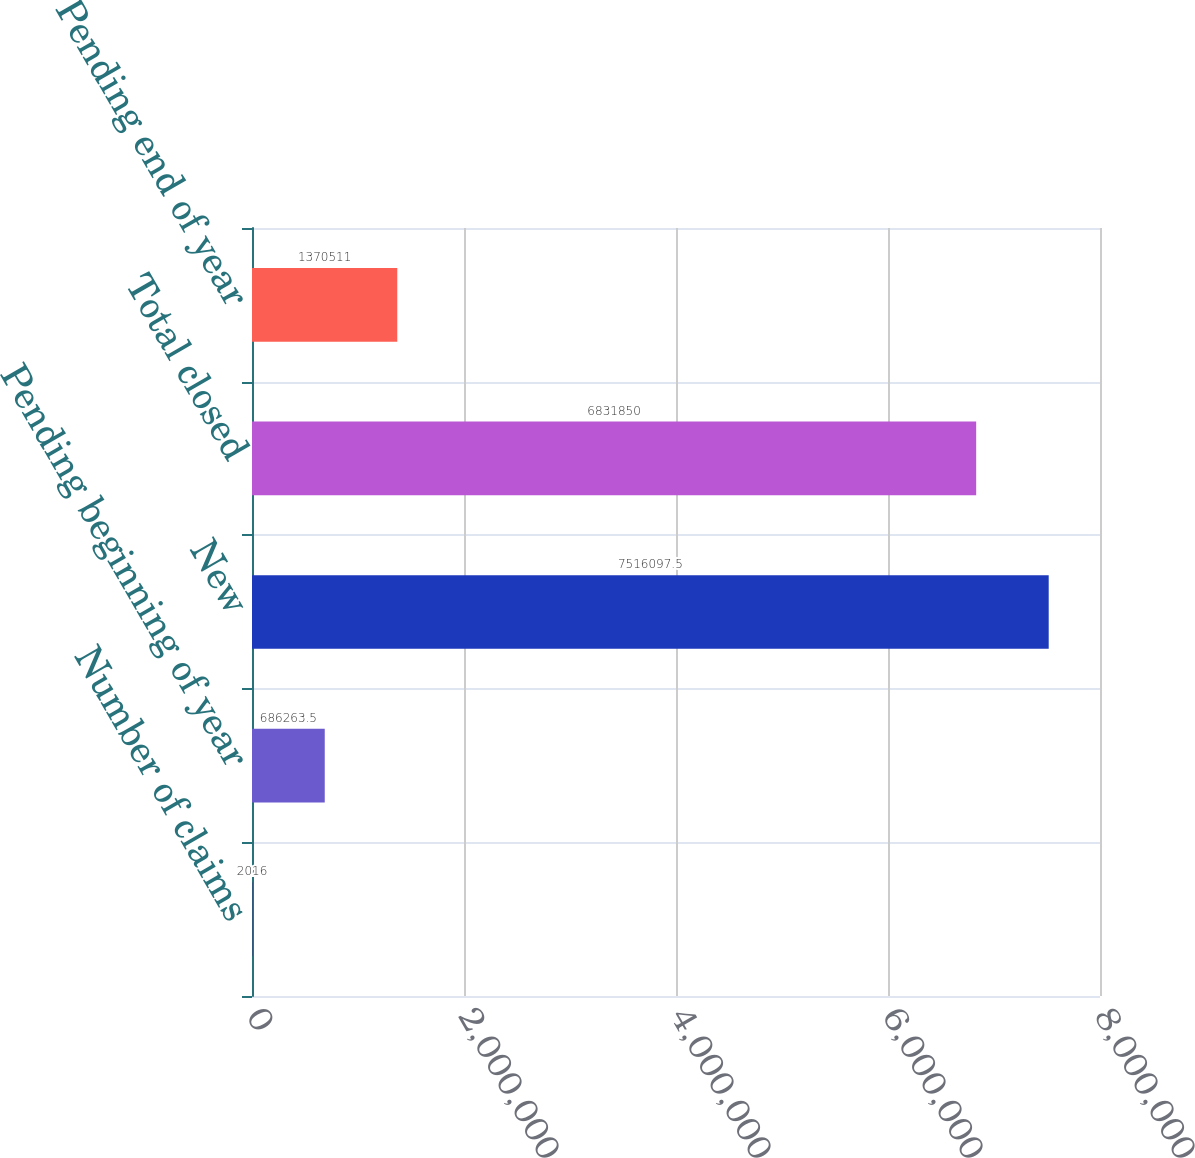<chart> <loc_0><loc_0><loc_500><loc_500><bar_chart><fcel>Number of claims<fcel>Pending beginning of year<fcel>New<fcel>Total closed<fcel>Pending end of year<nl><fcel>2016<fcel>686264<fcel>7.5161e+06<fcel>6.83185e+06<fcel>1.37051e+06<nl></chart> 